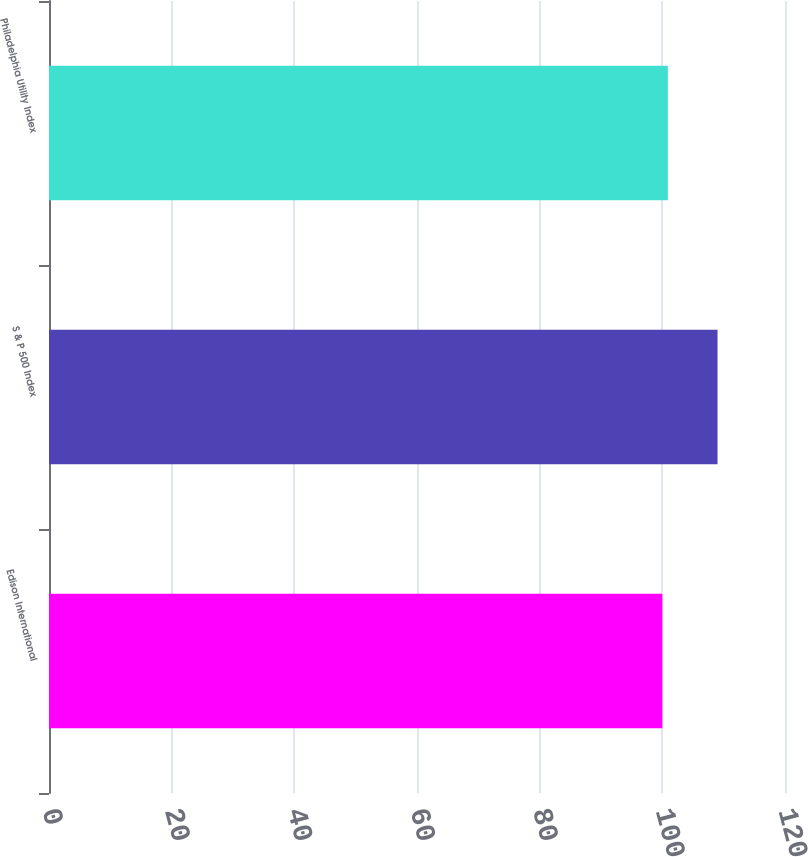Convert chart. <chart><loc_0><loc_0><loc_500><loc_500><bar_chart><fcel>Edison International<fcel>S & P 500 Index<fcel>Philadelphia Utility Index<nl><fcel>100<fcel>109<fcel>100.9<nl></chart> 